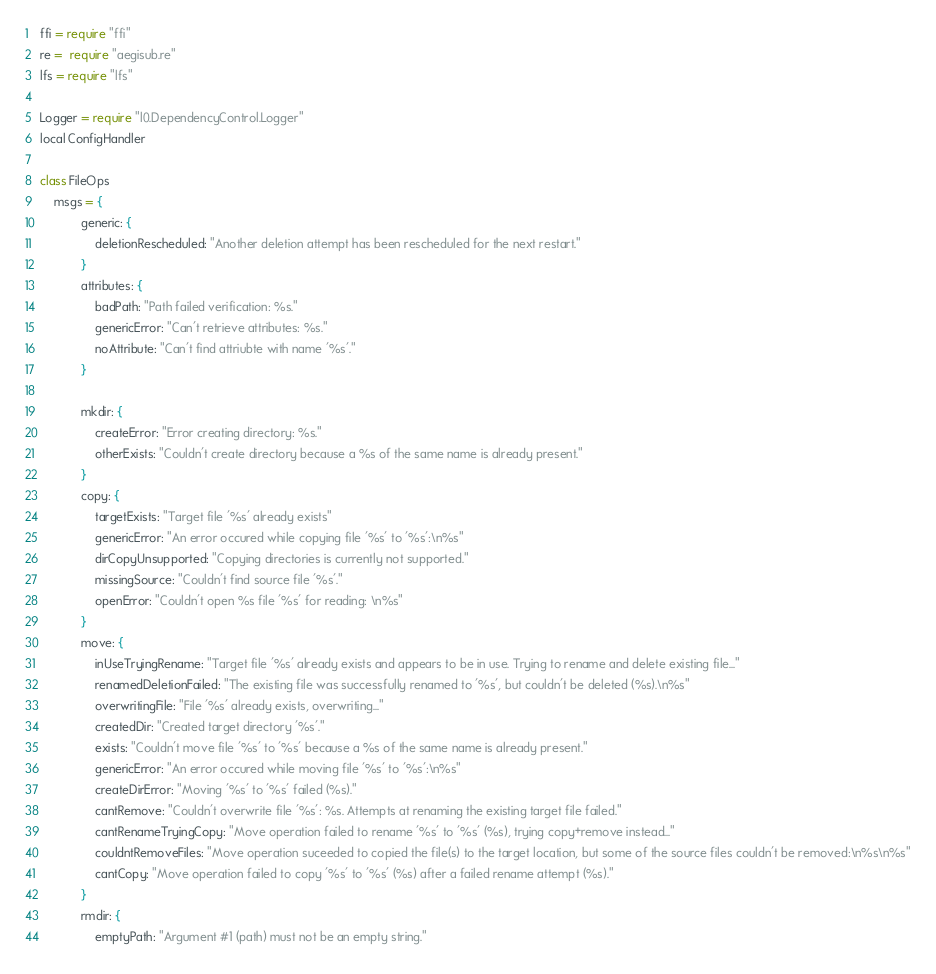Convert code to text. <code><loc_0><loc_0><loc_500><loc_500><_MoonScript_>ffi = require "ffi"
re =  require "aegisub.re"
lfs = require "lfs"

Logger = require "l0.DependencyControl.Logger"
local ConfigHandler

class FileOps
    msgs = {
            generic: {
                deletionRescheduled: "Another deletion attempt has been rescheduled for the next restart."
            }
            attributes: {
                badPath: "Path failed verification: %s."
                genericError: "Can't retrieve attributes: %s."
                noAttribute: "Can't find attriubte with name '%s'."
            }

            mkdir: {
                createError: "Error creating directory: %s."
                otherExists: "Couldn't create directory because a %s of the same name is already present."
            }
            copy: {
                targetExists: "Target file '%s' already exists"
                genericError: "An error occured while copying file '%s' to '%s':\n%s"
                dirCopyUnsupported: "Copying directories is currently not supported."
                missingSource: "Couldn't find source file '%s'."
                openError: "Couldn't open %s file '%s' for reading: \n%s"
            }
            move: {
                inUseTryingRename: "Target file '%s' already exists and appears to be in use. Trying to rename and delete existing file..."
                renamedDeletionFailed: "The existing file was successfully renamed to '%s', but couldn't be deleted (%s).\n%s"
                overwritingFile: "File '%s' already exists, overwriting..."
                createdDir: "Created target directory '%s'."
                exists: "Couldn't move file '%s' to '%s' because a %s of the same name is already present."
                genericError: "An error occured while moving file '%s' to '%s':\n%s"
                createDirError: "Moving '%s' to '%s' failed (%s)."
                cantRemove: "Couldn't overwrite file '%s': %s. Attempts at renaming the existing target file failed."
                cantRenameTryingCopy: "Move operation failed to rename '%s' to '%s' (%s), trying copy+remove instead..."
                couldntRemoveFiles: "Move operation suceeded to copied the file(s) to the target location, but some of the source files couldn't be removed:\n%s\n%s"
                cantCopy: "Move operation failed to copy '%s' to '%s' (%s) after a failed rename attempt (%s)."
            }
            rmdir: {
                emptyPath: "Argument #1 (path) must not be an empty string."</code> 